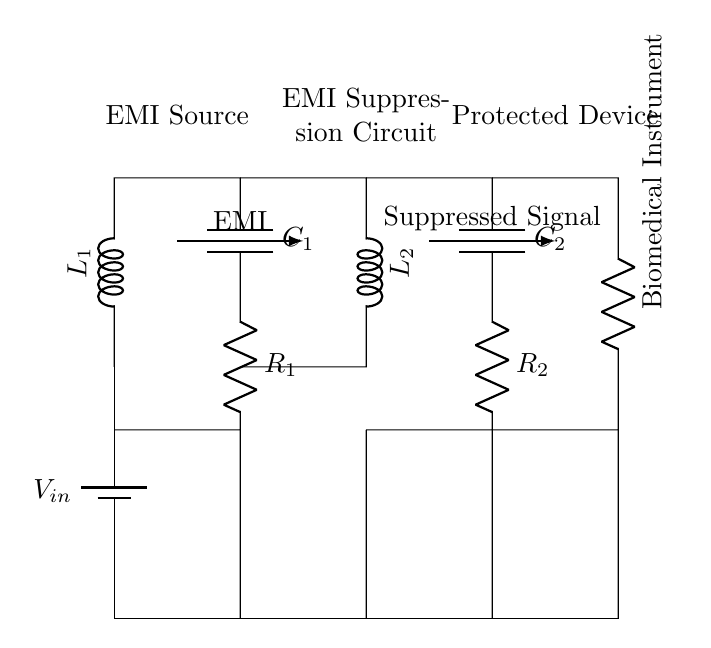What is the input voltage of this circuit? The input voltage is represented by V_in, which is the voltage supplied by the battery in the circuit.
Answer: V_in What is the purpose of the inductor L1 in this circuit? The purpose of the inductor L1 is to provide inductive reactance, which helps filter out high-frequency noise and prevent electromagnetic interference from affecting sensitive components.
Answer: EMI filtering How many capacitors are used in this circuit? The circuit diagram shows two capacitors, C1 and C2, which are used for EMI suppression.
Answer: Two What type of component is shown in the lowest section of the circuit? The lowest section shows a resistor labeled as a Biomedical Instrument, which indicates that it is a load that the circuit is protecting from EMI.
Answer: Resistor How does the EMI suppression circuit affect the signal? The EMI suppression circuit reduces the high-frequency noise present in the input signal, allowing a cleaner, suppressed signal to reach the biomedical instrument.
Answer: Cleaner signal What are the two main types of components used in the EMI suppression circuit? The two main types of components are inductors and capacitors, which work together to filter out electromagnetic interference.
Answer: Inductors and capacitors What is the function of R1 and R2 in this circuit? R1 and R2 provide a resistive path in the EMI filter, helping to dissipate energy and further stabilize the signal reaching the biomedical instrument.
Answer: Energy dissipation 